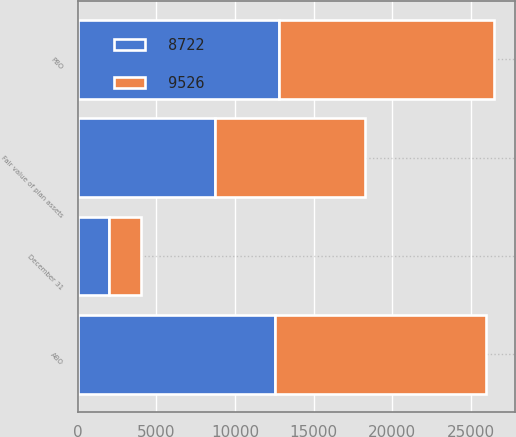Convert chart to OTSL. <chart><loc_0><loc_0><loc_500><loc_500><stacked_bar_chart><ecel><fcel>December 31<fcel>PBO<fcel>ABO<fcel>Fair value of plan assets<nl><fcel>9526<fcel>2017<fcel>13660<fcel>13398<fcel>9526<nl><fcel>8722<fcel>2016<fcel>12817<fcel>12557<fcel>8722<nl></chart> 